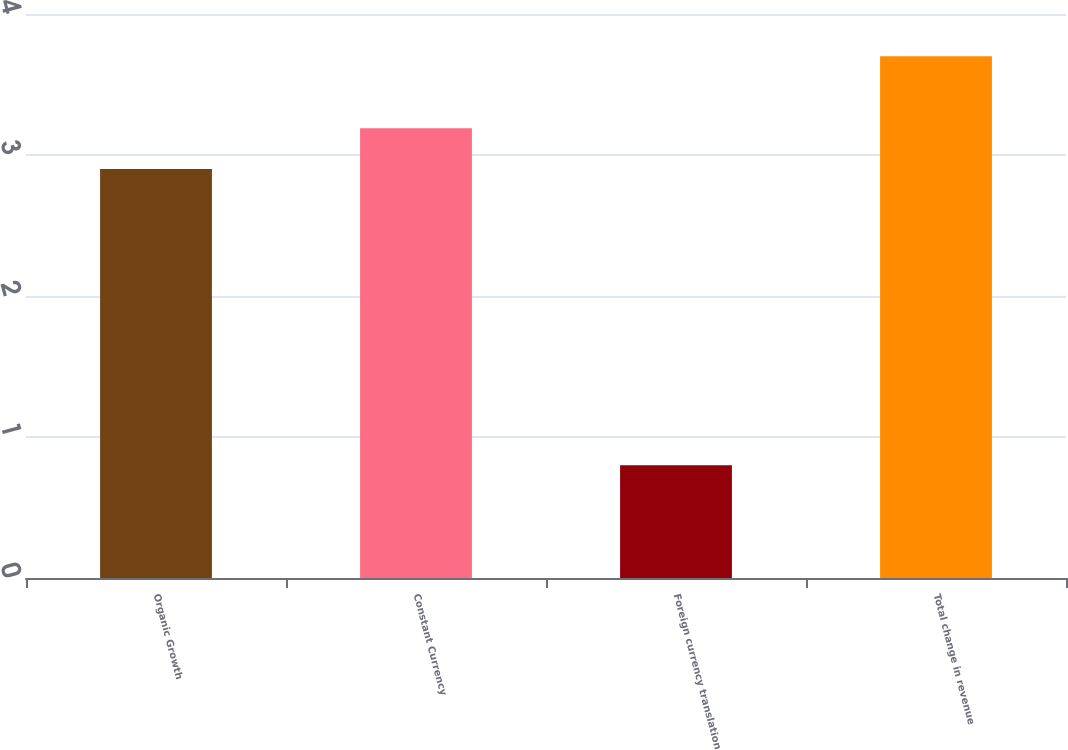Convert chart. <chart><loc_0><loc_0><loc_500><loc_500><bar_chart><fcel>Organic Growth<fcel>Constant Currency<fcel>Foreign currency translation<fcel>Total change in revenue<nl><fcel>2.9<fcel>3.19<fcel>0.8<fcel>3.7<nl></chart> 